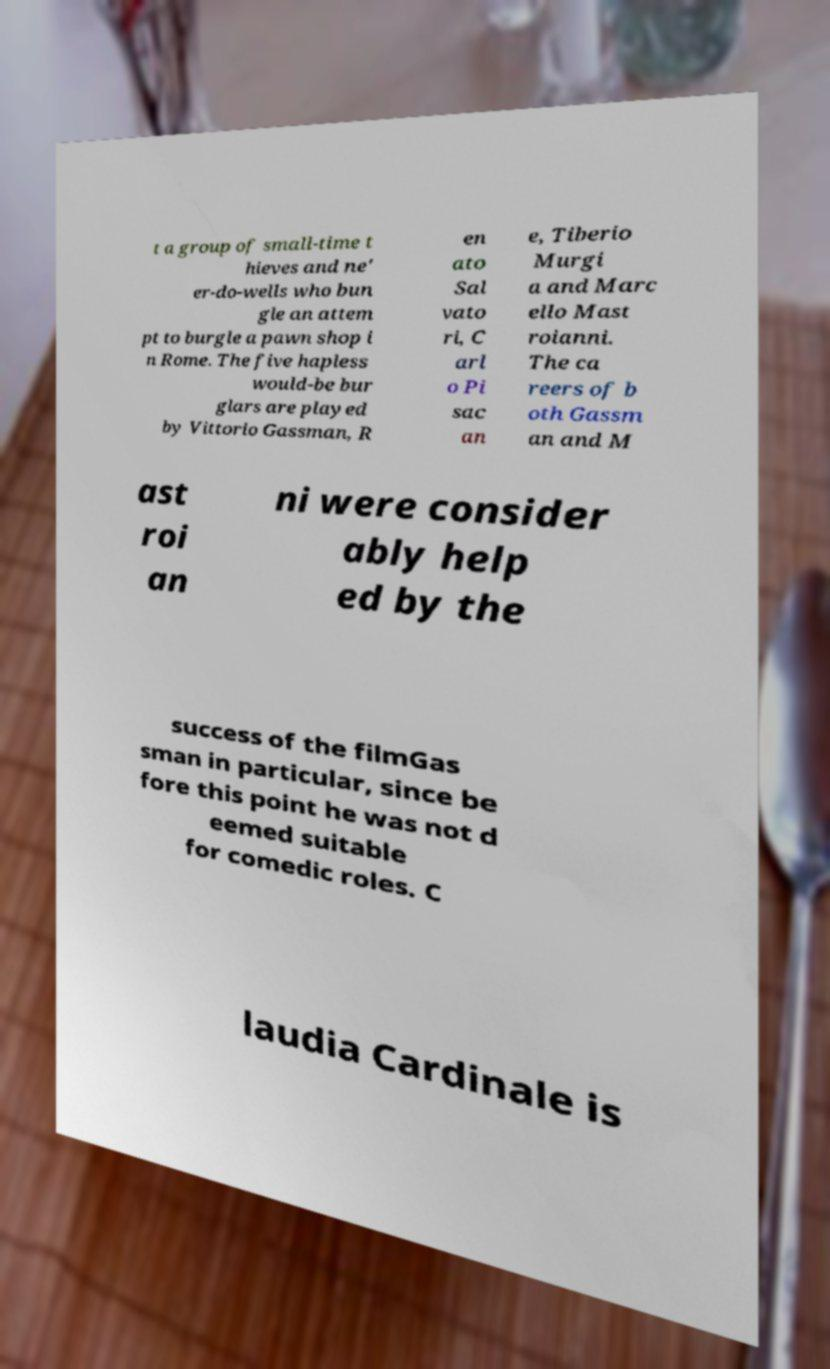Can you read and provide the text displayed in the image?This photo seems to have some interesting text. Can you extract and type it out for me? t a group of small-time t hieves and ne' er-do-wells who bun gle an attem pt to burgle a pawn shop i n Rome. The five hapless would-be bur glars are played by Vittorio Gassman, R en ato Sal vato ri, C arl o Pi sac an e, Tiberio Murgi a and Marc ello Mast roianni. The ca reers of b oth Gassm an and M ast roi an ni were consider ably help ed by the success of the filmGas sman in particular, since be fore this point he was not d eemed suitable for comedic roles. C laudia Cardinale is 